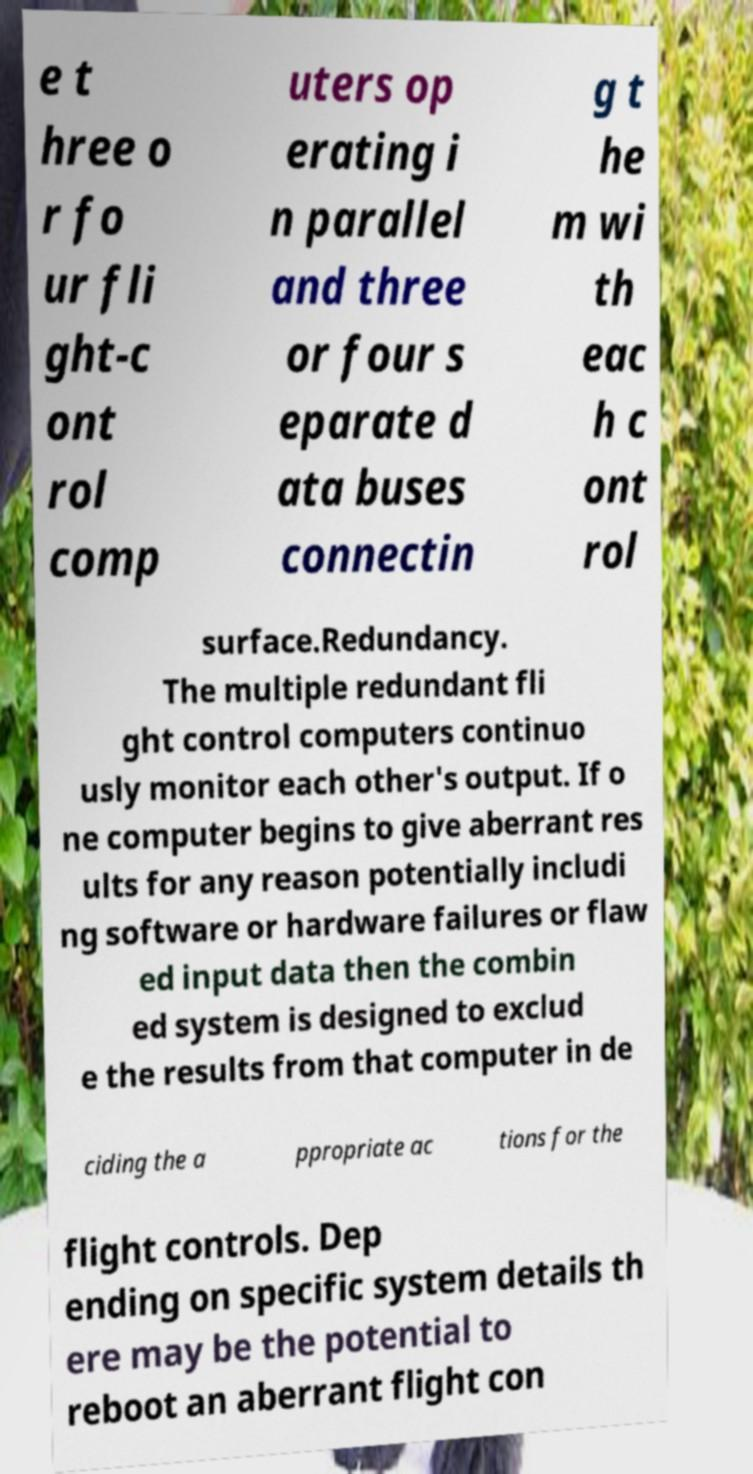Please identify and transcribe the text found in this image. e t hree o r fo ur fli ght-c ont rol comp uters op erating i n parallel and three or four s eparate d ata buses connectin g t he m wi th eac h c ont rol surface.Redundancy. The multiple redundant fli ght control computers continuo usly monitor each other's output. If o ne computer begins to give aberrant res ults for any reason potentially includi ng software or hardware failures or flaw ed input data then the combin ed system is designed to exclud e the results from that computer in de ciding the a ppropriate ac tions for the flight controls. Dep ending on specific system details th ere may be the potential to reboot an aberrant flight con 